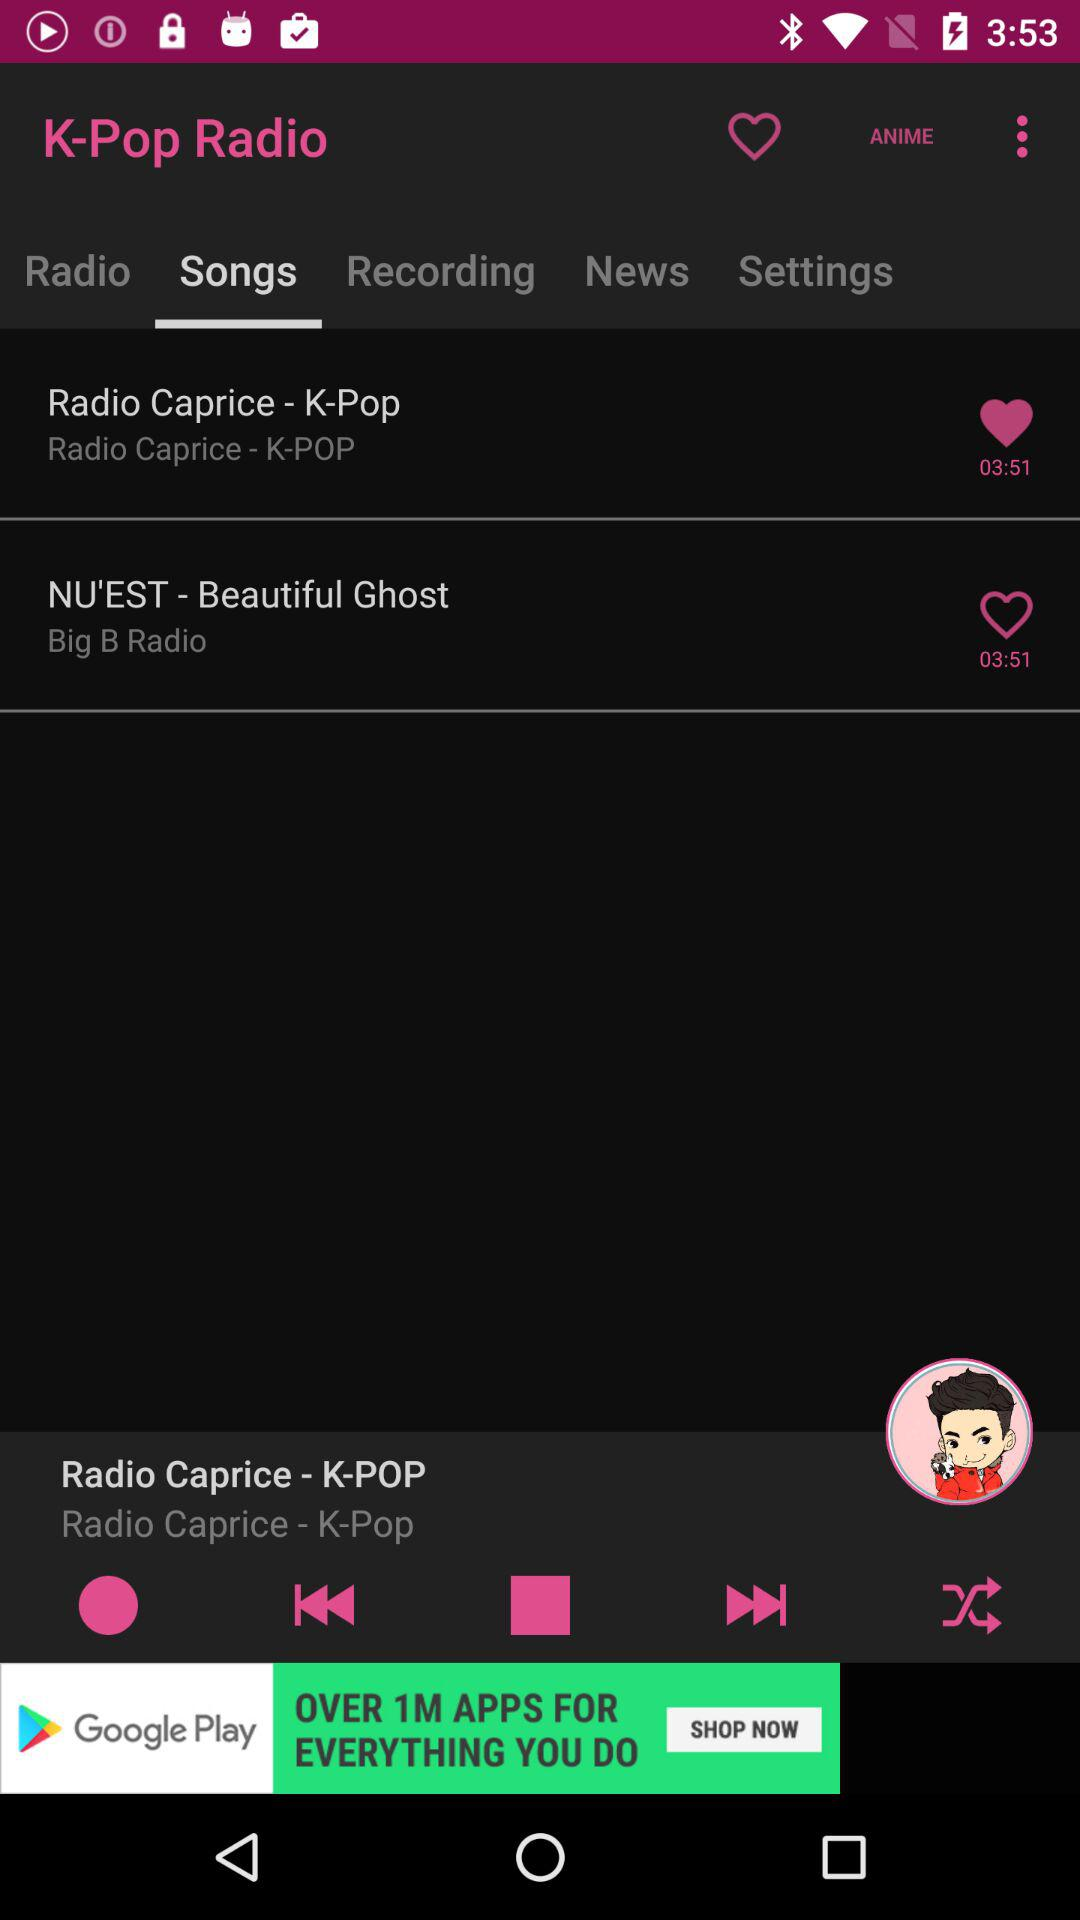What is the duration of "Radio Caprice - K-Pop"? The duration of "Radio Caprice - K-Pop" is 3 minutes and 51 seconds. 